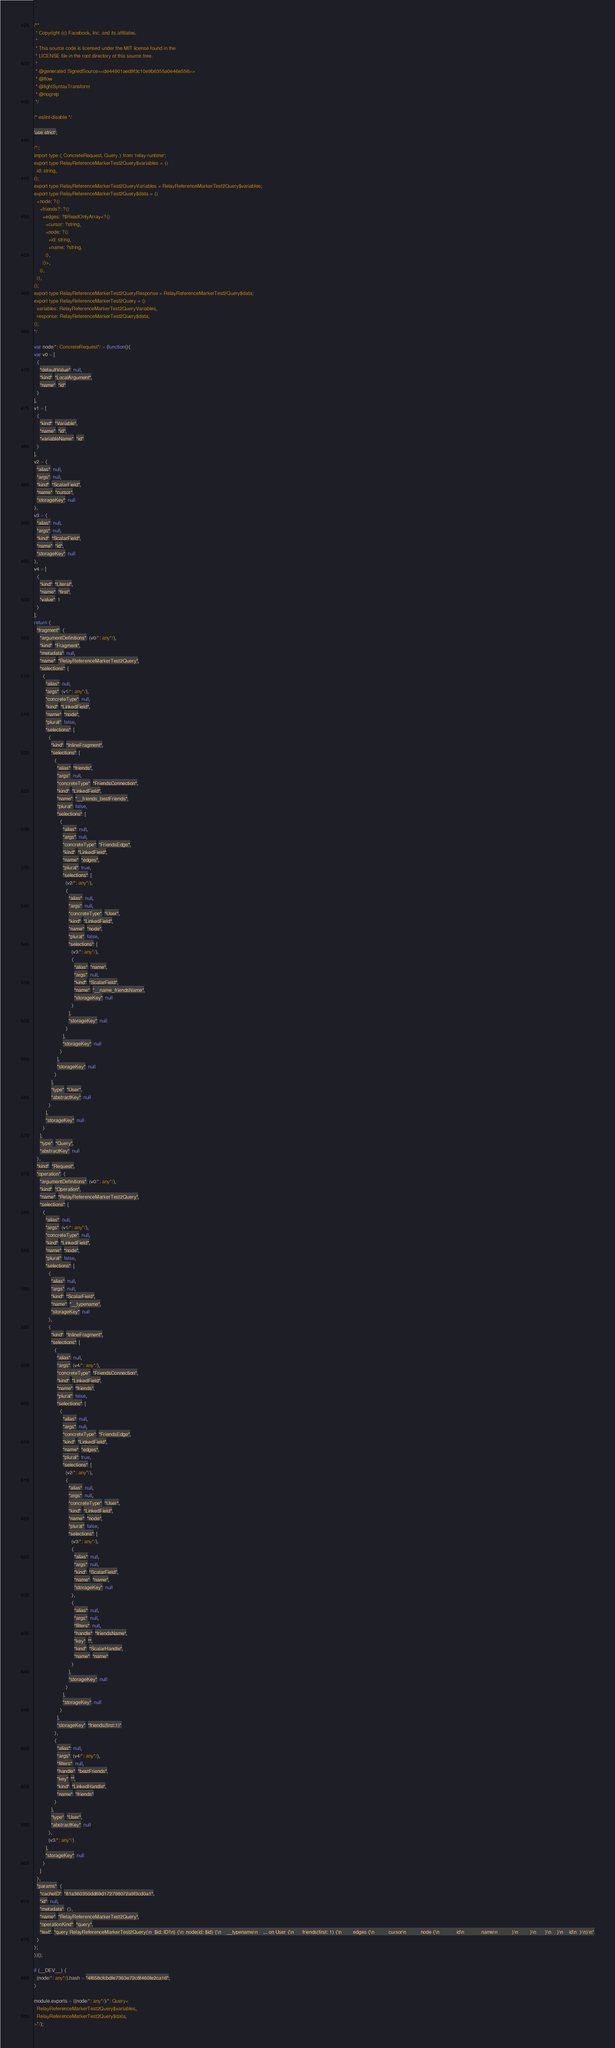Convert code to text. <code><loc_0><loc_0><loc_500><loc_500><_JavaScript_>/**
 * Copyright (c) Facebook, Inc. and its affiliates.
 * 
 * This source code is licensed under the MIT license found in the
 * LICENSE file in the root directory of this source tree.
 *
 * @generated SignedSource<<de44901aed9f3c10e9b6355a0e46e556>>
 * @flow
 * @lightSyntaxTransform
 * @nogrep
 */

/* eslint-disable */

'use strict';

/*::
import type { ConcreteRequest, Query } from 'relay-runtime';
export type RelayReferenceMarkerTest2Query$variables = {|
  id: string,
|};
export type RelayReferenceMarkerTest2QueryVariables = RelayReferenceMarkerTest2Query$variables;
export type RelayReferenceMarkerTest2Query$data = {|
  +node: ?{|
    +friends?: ?{|
      +edges: ?$ReadOnlyArray<?{|
        +cursor: ?string,
        +node: ?{|
          +id: string,
          +name: ?string,
        |},
      |}>,
    |},
  |},
|};
export type RelayReferenceMarkerTest2QueryResponse = RelayReferenceMarkerTest2Query$data;
export type RelayReferenceMarkerTest2Query = {|
  variables: RelayReferenceMarkerTest2QueryVariables,
  response: RelayReferenceMarkerTest2Query$data,
|};
*/

var node/*: ConcreteRequest*/ = (function(){
var v0 = [
  {
    "defaultValue": null,
    "kind": "LocalArgument",
    "name": "id"
  }
],
v1 = [
  {
    "kind": "Variable",
    "name": "id",
    "variableName": "id"
  }
],
v2 = {
  "alias": null,
  "args": null,
  "kind": "ScalarField",
  "name": "cursor",
  "storageKey": null
},
v3 = {
  "alias": null,
  "args": null,
  "kind": "ScalarField",
  "name": "id",
  "storageKey": null
},
v4 = [
  {
    "kind": "Literal",
    "name": "first",
    "value": 1
  }
];
return {
  "fragment": {
    "argumentDefinitions": (v0/*: any*/),
    "kind": "Fragment",
    "metadata": null,
    "name": "RelayReferenceMarkerTest2Query",
    "selections": [
      {
        "alias": null,
        "args": (v1/*: any*/),
        "concreteType": null,
        "kind": "LinkedField",
        "name": "node",
        "plural": false,
        "selections": [
          {
            "kind": "InlineFragment",
            "selections": [
              {
                "alias": "friends",
                "args": null,
                "concreteType": "FriendsConnection",
                "kind": "LinkedField",
                "name": "__friends_bestFriends",
                "plural": false,
                "selections": [
                  {
                    "alias": null,
                    "args": null,
                    "concreteType": "FriendsEdge",
                    "kind": "LinkedField",
                    "name": "edges",
                    "plural": true,
                    "selections": [
                      (v2/*: any*/),
                      {
                        "alias": null,
                        "args": null,
                        "concreteType": "User",
                        "kind": "LinkedField",
                        "name": "node",
                        "plural": false,
                        "selections": [
                          (v3/*: any*/),
                          {
                            "alias": "name",
                            "args": null,
                            "kind": "ScalarField",
                            "name": "__name_friendsName",
                            "storageKey": null
                          }
                        ],
                        "storageKey": null
                      }
                    ],
                    "storageKey": null
                  }
                ],
                "storageKey": null
              }
            ],
            "type": "User",
            "abstractKey": null
          }
        ],
        "storageKey": null
      }
    ],
    "type": "Query",
    "abstractKey": null
  },
  "kind": "Request",
  "operation": {
    "argumentDefinitions": (v0/*: any*/),
    "kind": "Operation",
    "name": "RelayReferenceMarkerTest2Query",
    "selections": [
      {
        "alias": null,
        "args": (v1/*: any*/),
        "concreteType": null,
        "kind": "LinkedField",
        "name": "node",
        "plural": false,
        "selections": [
          {
            "alias": null,
            "args": null,
            "kind": "ScalarField",
            "name": "__typename",
            "storageKey": null
          },
          {
            "kind": "InlineFragment",
            "selections": [
              {
                "alias": null,
                "args": (v4/*: any*/),
                "concreteType": "FriendsConnection",
                "kind": "LinkedField",
                "name": "friends",
                "plural": false,
                "selections": [
                  {
                    "alias": null,
                    "args": null,
                    "concreteType": "FriendsEdge",
                    "kind": "LinkedField",
                    "name": "edges",
                    "plural": true,
                    "selections": [
                      (v2/*: any*/),
                      {
                        "alias": null,
                        "args": null,
                        "concreteType": "User",
                        "kind": "LinkedField",
                        "name": "node",
                        "plural": false,
                        "selections": [
                          (v3/*: any*/),
                          {
                            "alias": null,
                            "args": null,
                            "kind": "ScalarField",
                            "name": "name",
                            "storageKey": null
                          },
                          {
                            "alias": null,
                            "args": null,
                            "filters": null,
                            "handle": "friendsName",
                            "key": "",
                            "kind": "ScalarHandle",
                            "name": "name"
                          }
                        ],
                        "storageKey": null
                      }
                    ],
                    "storageKey": null
                  }
                ],
                "storageKey": "friends(first:1)"
              },
              {
                "alias": null,
                "args": (v4/*: any*/),
                "filters": null,
                "handle": "bestFriends",
                "key": "",
                "kind": "LinkedHandle",
                "name": "friends"
              }
            ],
            "type": "User",
            "abstractKey": null
          },
          (v3/*: any*/)
        ],
        "storageKey": null
      }
    ]
  },
  "params": {
    "cacheID": "81a360350dd69d172798072a9f3cd0a1",
    "id": null,
    "metadata": {},
    "name": "RelayReferenceMarkerTest2Query",
    "operationKind": "query",
    "text": "query RelayReferenceMarkerTest2Query(\n  $id: ID!\n) {\n  node(id: $id) {\n    __typename\n    ... on User {\n      friends(first: 1) {\n        edges {\n          cursor\n          node {\n            id\n            name\n          }\n        }\n      }\n    }\n    id\n  }\n}\n"
  }
};
})();

if (__DEV__) {
  (node/*: any*/).hash = "4f658cfcbdfe7363e72c8f460fe2ca16";
}

module.exports = ((node/*: any*/)/*: Query<
  RelayReferenceMarkerTest2Query$variables,
  RelayReferenceMarkerTest2Query$data,
>*/);
</code> 